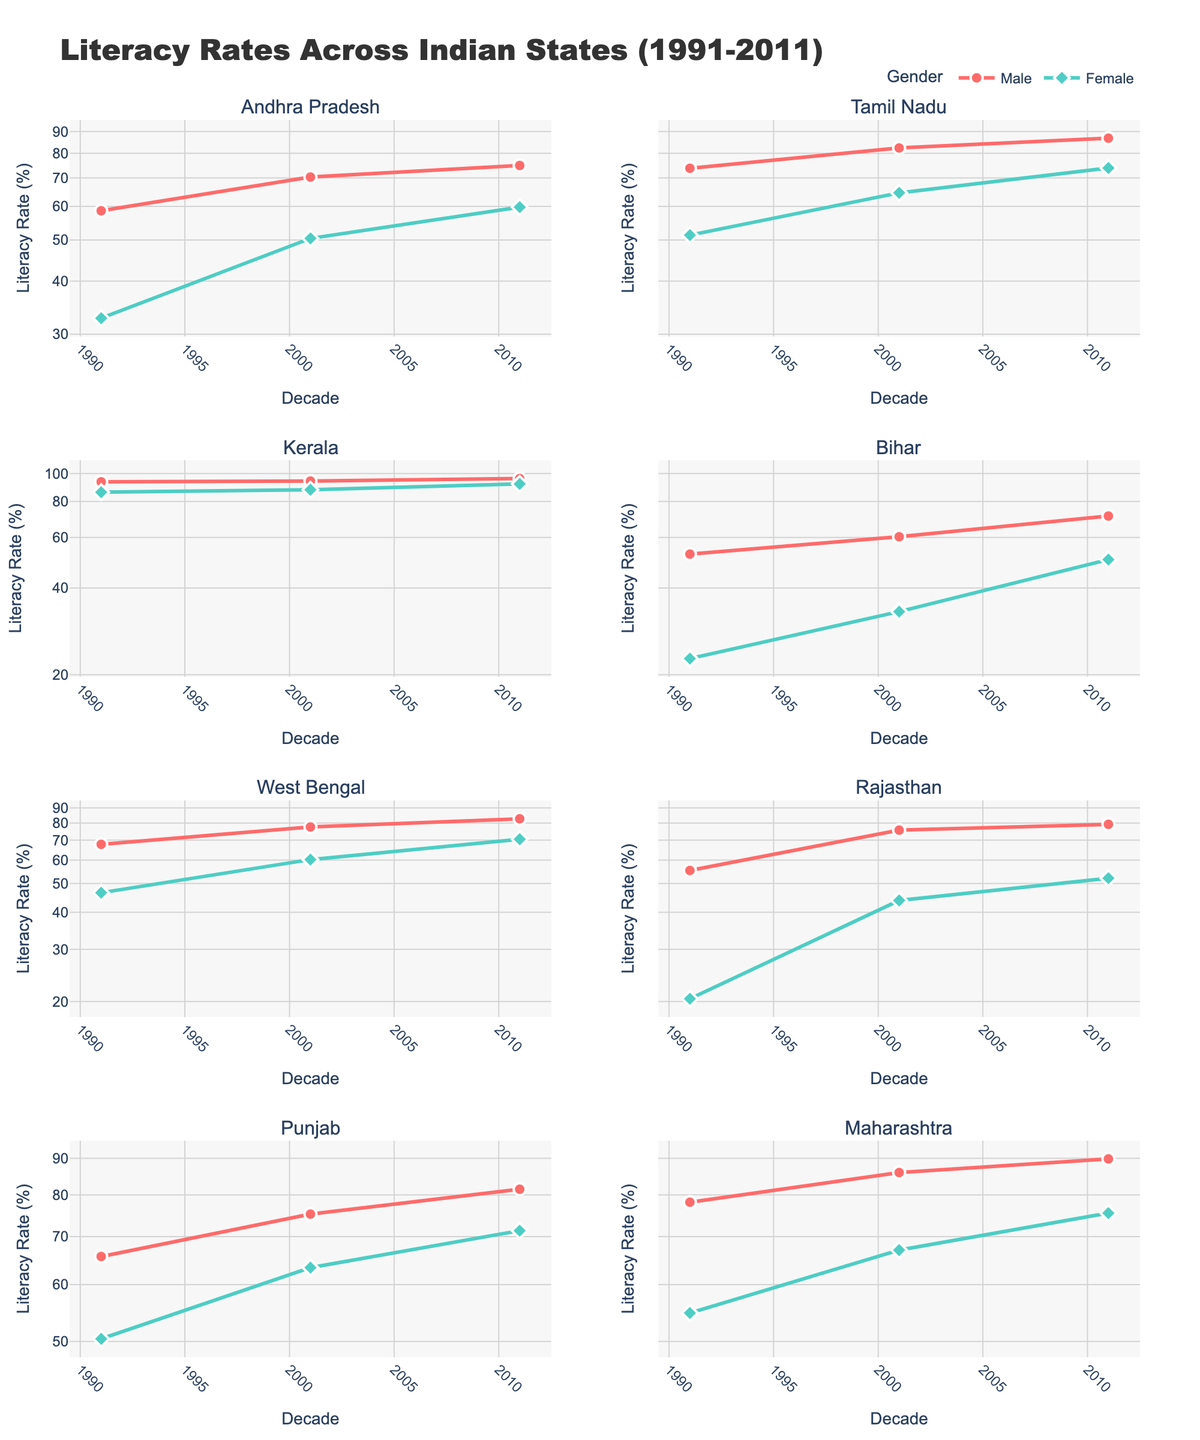Which state had the highest male literacy rate in 2011? Kerala had the highest male literacy rate in 2011. This can be seen by comparing the last data points for male literacy rates across the subplots for different states. Kerala has the highest value.
Answer: Kerala Which state showed the biggest improvement in female literacy rates between 1991 and 2011? To find the biggest improvement, we need to calculate the difference in female literacy rates between 1991 and 2011 for each state and compare them. Bihar improved from 22.75 in 1991 to 50.25 in 2011, an increase of 27.5 points, which is the largest among all states.
Answer: Bihar How do the literacy rates of males and females in Rajasthan compare over the three decades? In Rajasthan, male literacy rates increased from 55.35 to 79.19 from 1991 to 2011, while female literacy rates increased from 20.44 to 52.12 during the same period. This shows significant improvement in both genders, but females had a larger relative increase.
Answer: Both increased; females had a larger relative increase Which gender has consistently shown higher literacy rates within each state? By examining each subplot, it is clear that males have consistently shown higher literacy rates than females in each state over the three decades. In each subplot, the male curve is always higher than the female curve.
Answer: Males What is the trend in the literacy rate in Tamil Nadu for both genders from 1991 to 2011? Both male and female literacy rates in Tamil Nadu show an upward trend from 1991 to 2011. Specifically, male literacy increased from 73.75 to 86.81 while female literacy rose from 51.33 to 73.86.
Answer: Upward trend for both genders Which state had the lower male literacy rate in 2001: Andhra Pradesh or Bihar? To determine this, compare the male literacy rates in 2001 for both states. Andhra Pradesh had a male literacy rate of 70.32, while Bihar had 60.32, so Bihar had the lower rate.
Answer: Bihar What is the ratio of male to female literacy rates in Kerala in 2011? The male literacy rate in Kerala in 2011 was 96.11, and the female literacy rate was 92.07. The ratio is calculated as 96.11 / 92.07 ≈ 1.04.
Answer: 1.04 How did Punjab’s female literacy rates change from 1991 to 2011? Punjab’s female literacy rate increased from 50.41 in 1991 to 71.34 in 2011, showing a continuous upward trend over the three decades.
Answer: Increased from 50.41 to 71.34 Which state had the most balanced literacy rates between genders in 2011? Kerala had the most balanced literacy rates between genders in 2011. The male literacy rate was 96.11, and the female literacy rate was 92.07, showing the smallest gap among all states.
Answer: Kerala 